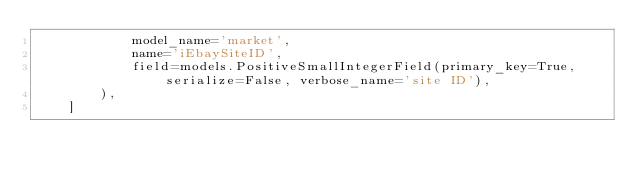<code> <loc_0><loc_0><loc_500><loc_500><_Python_>            model_name='market',
            name='iEbaySiteID',
            field=models.PositiveSmallIntegerField(primary_key=True, serialize=False, verbose_name='site ID'),
        ),
    ]
</code> 